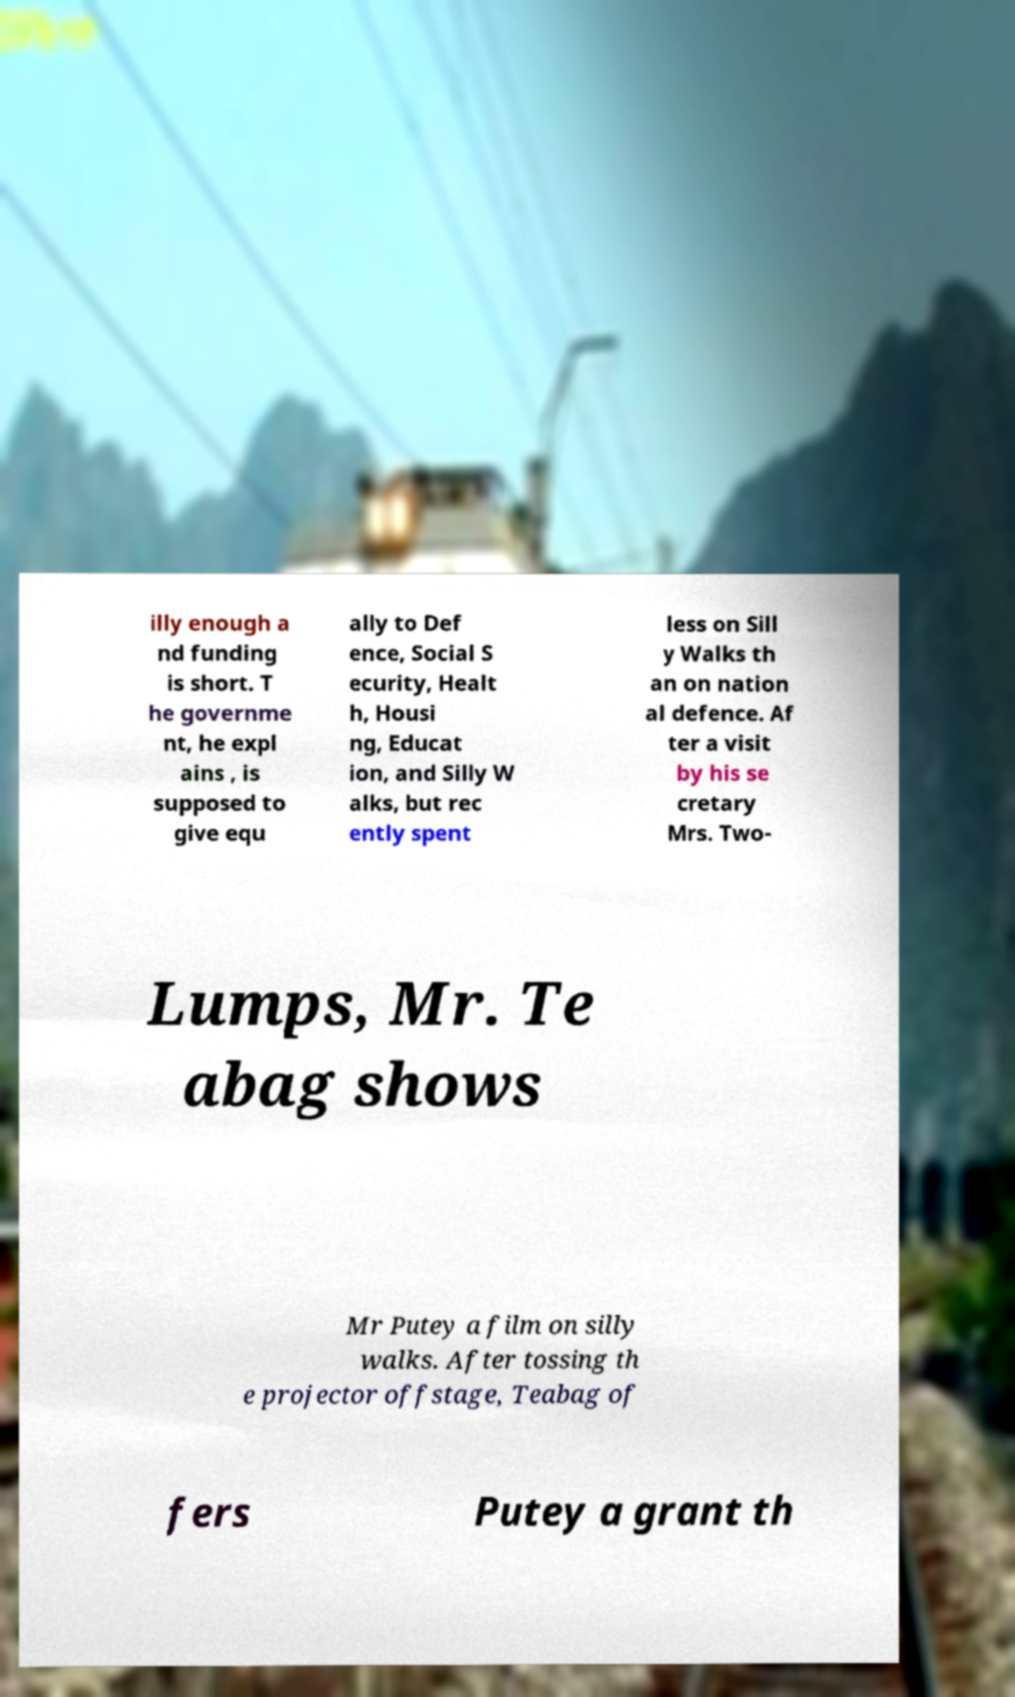Please read and relay the text visible in this image. What does it say? illy enough a nd funding is short. T he governme nt, he expl ains , is supposed to give equ ally to Def ence, Social S ecurity, Healt h, Housi ng, Educat ion, and Silly W alks, but rec ently spent less on Sill y Walks th an on nation al defence. Af ter a visit by his se cretary Mrs. Two- Lumps, Mr. Te abag shows Mr Putey a film on silly walks. After tossing th e projector offstage, Teabag of fers Putey a grant th 